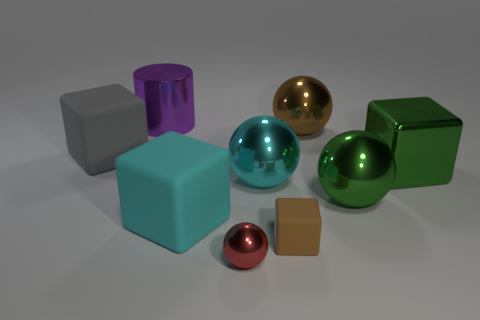Subtract 2 cubes. How many cubes are left? 2 Subtract all large gray blocks. How many blocks are left? 3 Subtract all yellow balls. Subtract all brown cylinders. How many balls are left? 4 Subtract all cubes. How many objects are left? 5 Subtract all shiny cylinders. Subtract all big green balls. How many objects are left? 7 Add 4 big green objects. How many big green objects are left? 6 Add 9 brown blocks. How many brown blocks exist? 10 Subtract 0 blue cylinders. How many objects are left? 9 